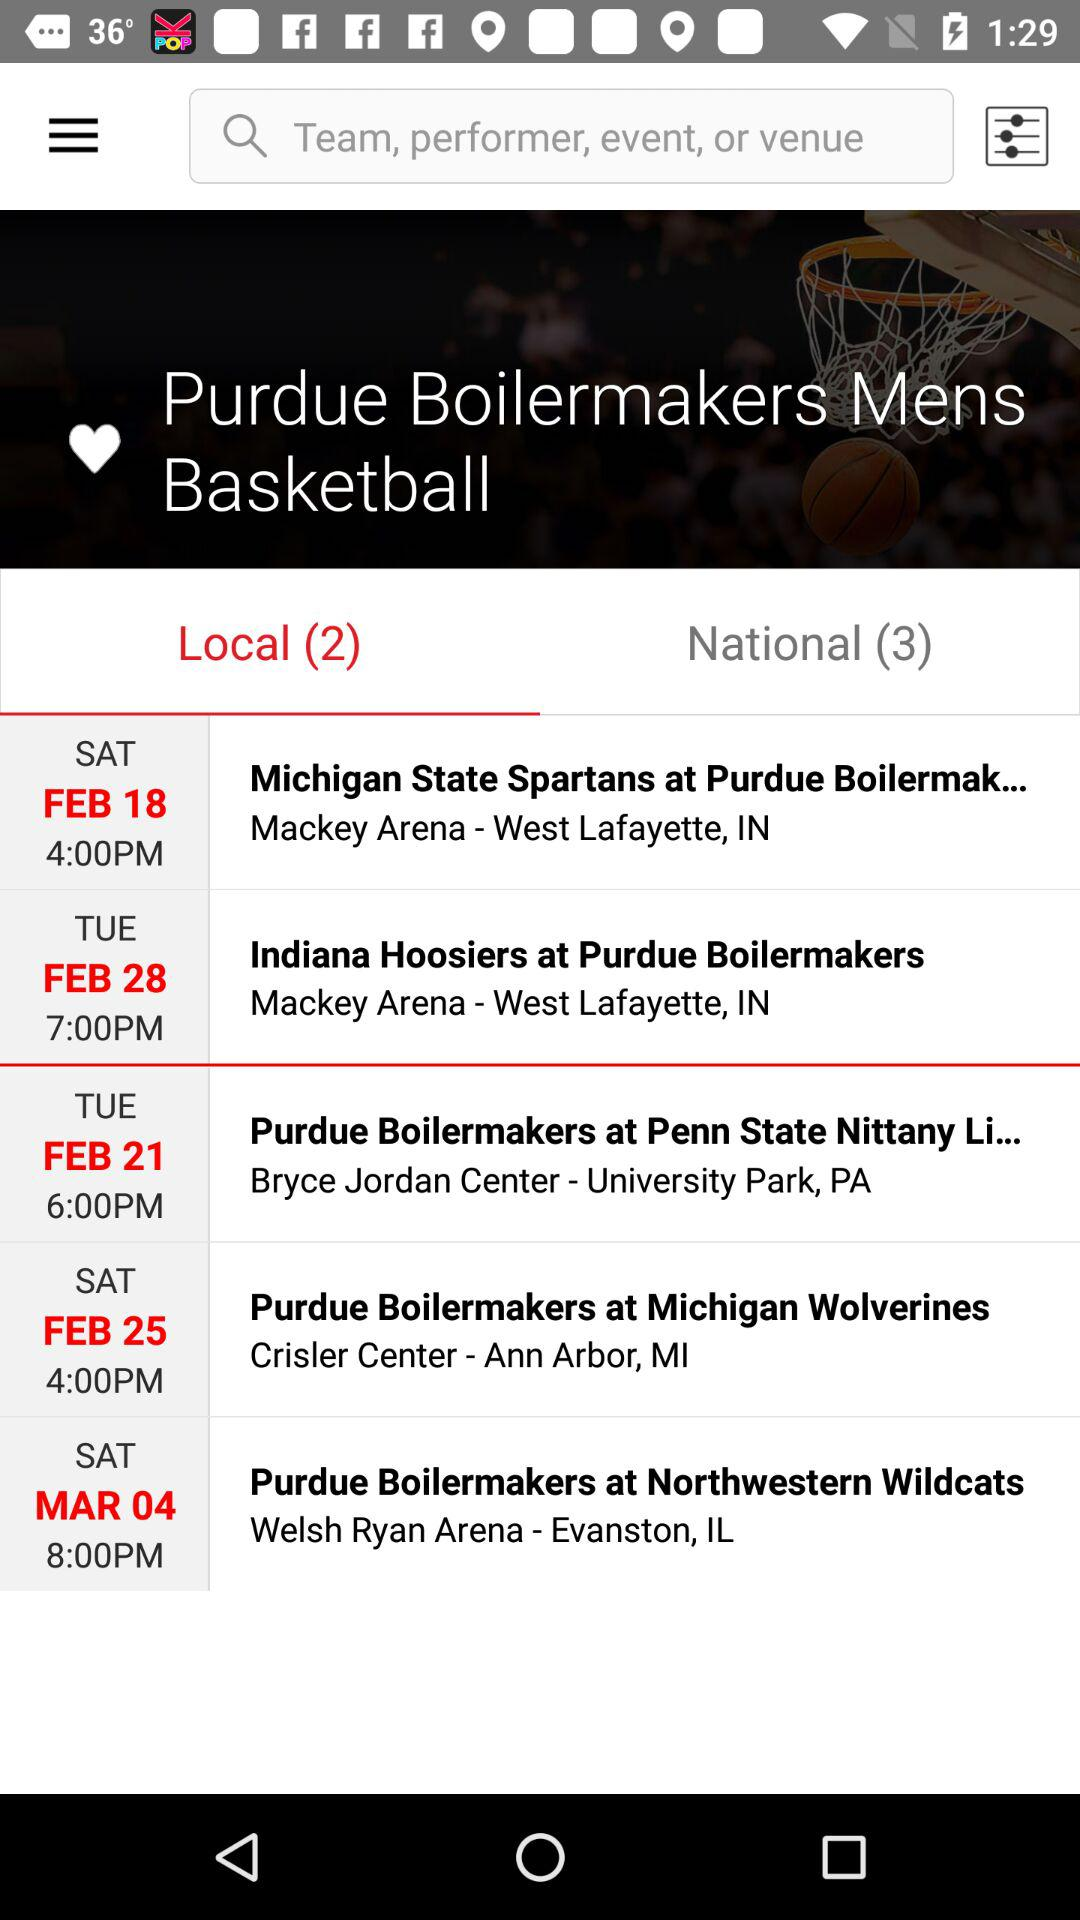What is the count for the selected tab? The count for the selected tab is 2. 